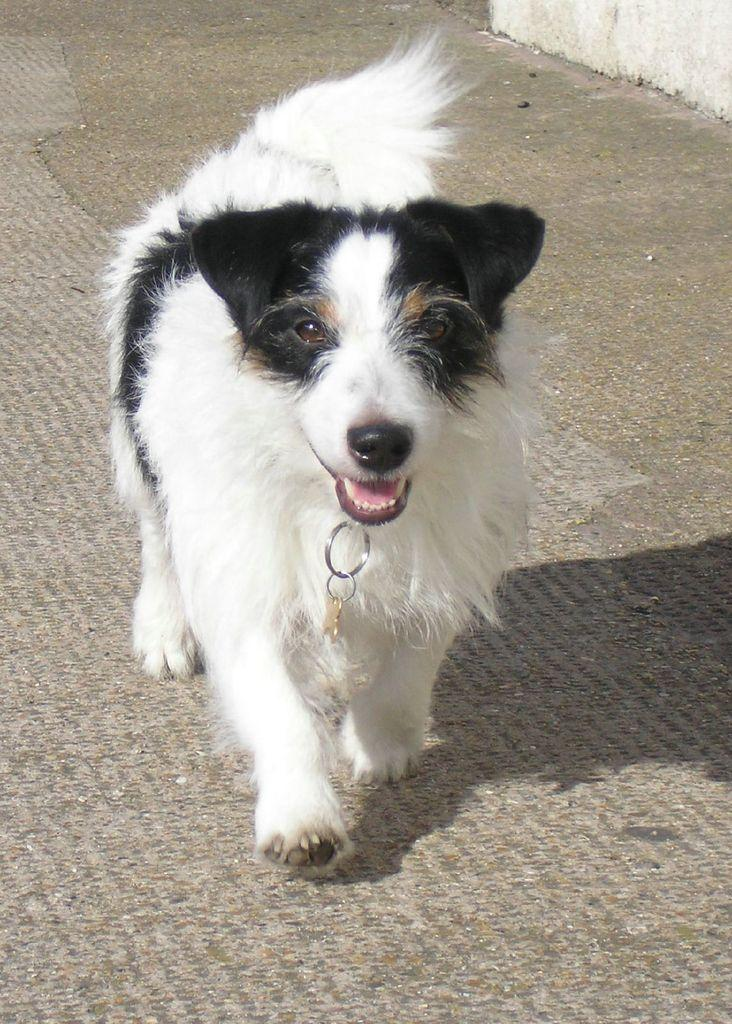What type of animal is present in the image? There is a dog in the image. Can you describe the position of the dog in the image? The dog is on the ground in the image. What type of smile can be seen on the dog's face in the image? Dogs do not have the ability to smile, so there is no smile visible on the dog's face in the image. Can you describe the weather conditions in the image? The provided facts do not mention any weather conditions, so it cannot be determined from the image. 